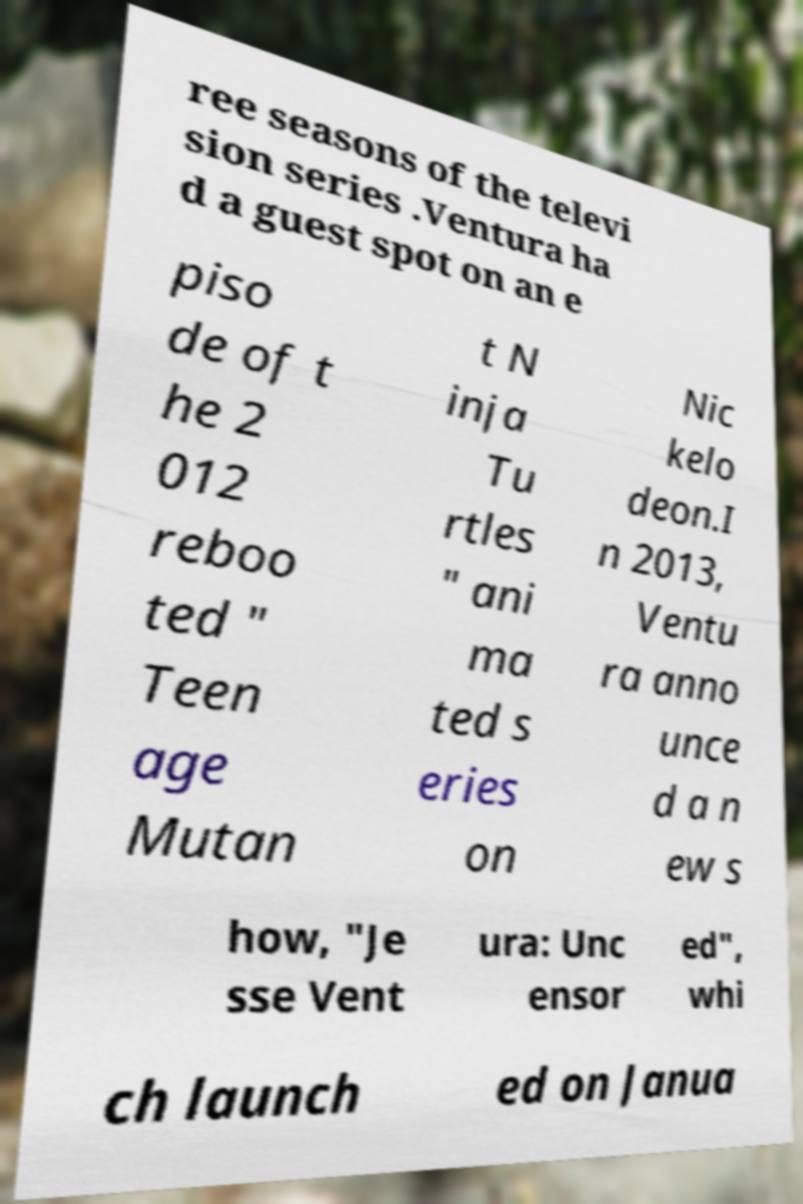Can you read and provide the text displayed in the image?This photo seems to have some interesting text. Can you extract and type it out for me? ree seasons of the televi sion series .Ventura ha d a guest spot on an e piso de of t he 2 012 reboo ted " Teen age Mutan t N inja Tu rtles " ani ma ted s eries on Nic kelo deon.I n 2013, Ventu ra anno unce d a n ew s how, "Je sse Vent ura: Unc ensor ed", whi ch launch ed on Janua 